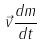<formula> <loc_0><loc_0><loc_500><loc_500>\vec { v } \frac { d m } { d t }</formula> 